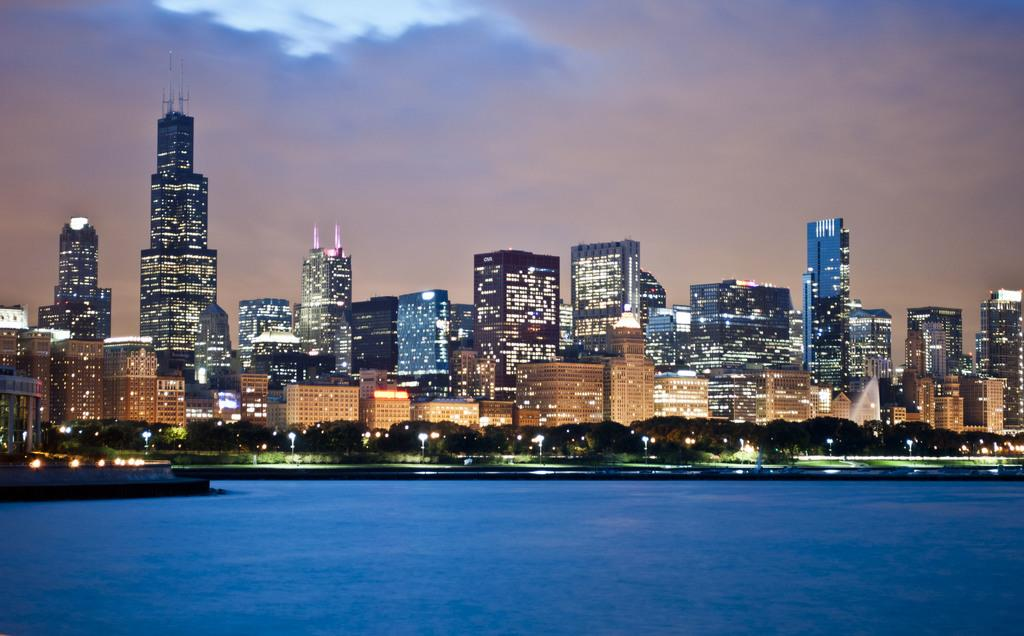What type of natural feature can be seen in the image? There is a sea in the image. What man-made structures are visible in the image? There are buildings with lights in the image. What type of vegetation is present in the image? There are trees in the image. What is visible in the sky in the image? The sky is visible in the image, and clouds are present. How many beds can be seen in the image? There are no beds present in the image. What type of jewel is embedded in the clouds in the image? There are no jewels present in the image, and the clouds are not depicted as having any embedded objects. 